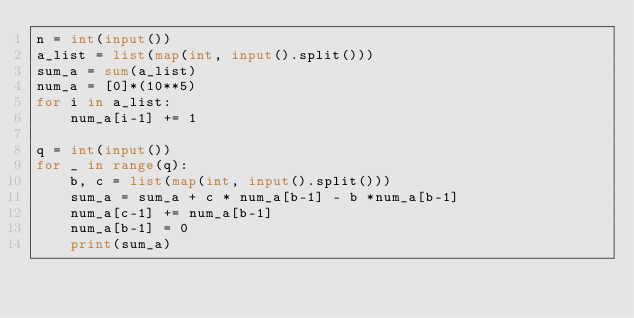<code> <loc_0><loc_0><loc_500><loc_500><_Python_>n = int(input())
a_list = list(map(int, input().split()))
sum_a = sum(a_list)
num_a = [0]*(10**5)
for i in a_list:
    num_a[i-1] += 1
    
q = int(input())
for _ in range(q):
    b, c = list(map(int, input().split()))
    sum_a = sum_a + c * num_a[b-1] - b *num_a[b-1]
    num_a[c-1] += num_a[b-1]
    num_a[b-1] = 0
    print(sum_a)</code> 